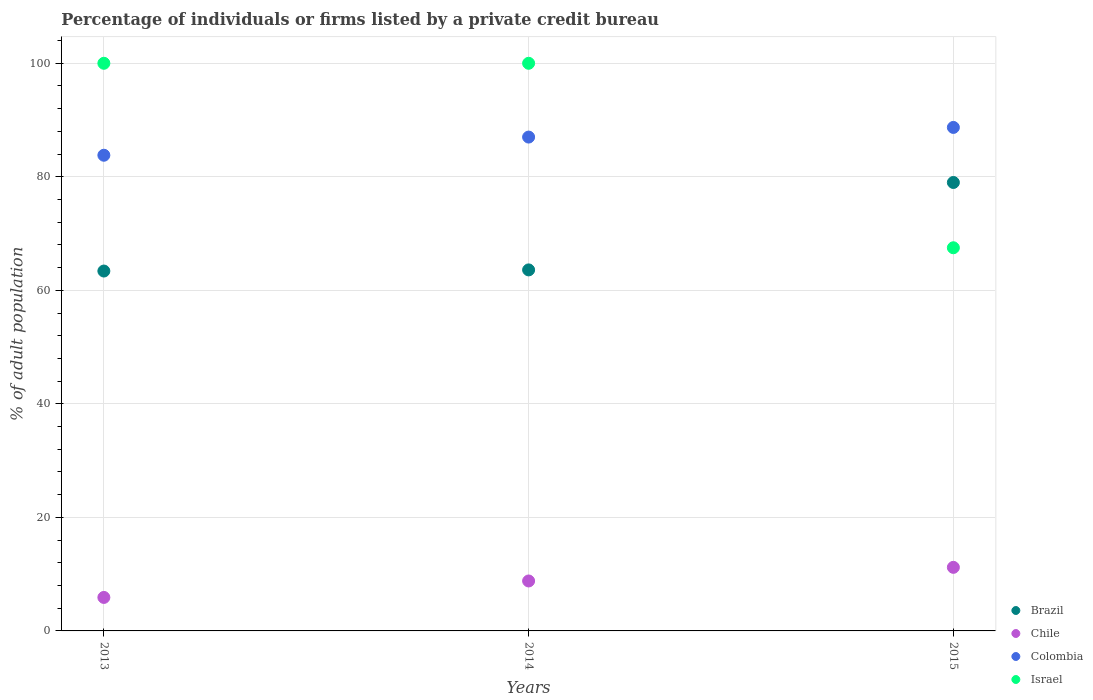What is the percentage of population listed by a private credit bureau in Israel in 2014?
Keep it short and to the point. 100. Across all years, what is the maximum percentage of population listed by a private credit bureau in Brazil?
Provide a succinct answer. 79. Across all years, what is the minimum percentage of population listed by a private credit bureau in Brazil?
Provide a succinct answer. 63.4. In which year was the percentage of population listed by a private credit bureau in Chile maximum?
Your response must be concise. 2015. What is the total percentage of population listed by a private credit bureau in Chile in the graph?
Your answer should be compact. 25.9. What is the difference between the percentage of population listed by a private credit bureau in Israel in 2013 and that in 2014?
Ensure brevity in your answer.  0. What is the difference between the percentage of population listed by a private credit bureau in Israel in 2013 and the percentage of population listed by a private credit bureau in Chile in 2014?
Make the answer very short. 91.2. What is the average percentage of population listed by a private credit bureau in Colombia per year?
Your answer should be compact. 86.5. In the year 2014, what is the difference between the percentage of population listed by a private credit bureau in Colombia and percentage of population listed by a private credit bureau in Brazil?
Keep it short and to the point. 23.4. In how many years, is the percentage of population listed by a private credit bureau in Colombia greater than 56 %?
Provide a succinct answer. 3. What is the ratio of the percentage of population listed by a private credit bureau in Colombia in 2014 to that in 2015?
Offer a terse response. 0.98. What is the difference between the highest and the lowest percentage of population listed by a private credit bureau in Brazil?
Offer a very short reply. 15.6. Is the sum of the percentage of population listed by a private credit bureau in Brazil in 2014 and 2015 greater than the maximum percentage of population listed by a private credit bureau in Israel across all years?
Your answer should be very brief. Yes. Is it the case that in every year, the sum of the percentage of population listed by a private credit bureau in Chile and percentage of population listed by a private credit bureau in Israel  is greater than the sum of percentage of population listed by a private credit bureau in Colombia and percentage of population listed by a private credit bureau in Brazil?
Provide a succinct answer. No. How many years are there in the graph?
Offer a very short reply. 3. What is the difference between two consecutive major ticks on the Y-axis?
Give a very brief answer. 20. Are the values on the major ticks of Y-axis written in scientific E-notation?
Make the answer very short. No. Does the graph contain grids?
Offer a terse response. Yes. How are the legend labels stacked?
Your answer should be very brief. Vertical. What is the title of the graph?
Offer a very short reply. Percentage of individuals or firms listed by a private credit bureau. Does "Luxembourg" appear as one of the legend labels in the graph?
Offer a very short reply. No. What is the label or title of the X-axis?
Your answer should be very brief. Years. What is the label or title of the Y-axis?
Offer a terse response. % of adult population. What is the % of adult population in Brazil in 2013?
Give a very brief answer. 63.4. What is the % of adult population of Chile in 2013?
Offer a very short reply. 5.9. What is the % of adult population of Colombia in 2013?
Your answer should be compact. 83.8. What is the % of adult population of Israel in 2013?
Your answer should be compact. 100. What is the % of adult population of Brazil in 2014?
Offer a terse response. 63.6. What is the % of adult population of Chile in 2014?
Your response must be concise. 8.8. What is the % of adult population of Israel in 2014?
Make the answer very short. 100. What is the % of adult population of Brazil in 2015?
Provide a succinct answer. 79. What is the % of adult population in Colombia in 2015?
Your response must be concise. 88.7. What is the % of adult population in Israel in 2015?
Your answer should be very brief. 67.5. Across all years, what is the maximum % of adult population in Brazil?
Provide a succinct answer. 79. Across all years, what is the maximum % of adult population of Colombia?
Give a very brief answer. 88.7. Across all years, what is the maximum % of adult population in Israel?
Your answer should be compact. 100. Across all years, what is the minimum % of adult population in Brazil?
Provide a short and direct response. 63.4. Across all years, what is the minimum % of adult population in Colombia?
Ensure brevity in your answer.  83.8. Across all years, what is the minimum % of adult population in Israel?
Your answer should be compact. 67.5. What is the total % of adult population of Brazil in the graph?
Offer a very short reply. 206. What is the total % of adult population in Chile in the graph?
Keep it short and to the point. 25.9. What is the total % of adult population of Colombia in the graph?
Your answer should be very brief. 259.5. What is the total % of adult population of Israel in the graph?
Keep it short and to the point. 267.5. What is the difference between the % of adult population in Chile in 2013 and that in 2014?
Provide a succinct answer. -2.9. What is the difference between the % of adult population of Colombia in 2013 and that in 2014?
Make the answer very short. -3.2. What is the difference between the % of adult population in Brazil in 2013 and that in 2015?
Ensure brevity in your answer.  -15.6. What is the difference between the % of adult population of Chile in 2013 and that in 2015?
Offer a very short reply. -5.3. What is the difference between the % of adult population in Israel in 2013 and that in 2015?
Make the answer very short. 32.5. What is the difference between the % of adult population of Brazil in 2014 and that in 2015?
Provide a succinct answer. -15.4. What is the difference between the % of adult population of Chile in 2014 and that in 2015?
Offer a very short reply. -2.4. What is the difference between the % of adult population in Israel in 2014 and that in 2015?
Provide a succinct answer. 32.5. What is the difference between the % of adult population in Brazil in 2013 and the % of adult population in Chile in 2014?
Keep it short and to the point. 54.6. What is the difference between the % of adult population of Brazil in 2013 and the % of adult population of Colombia in 2014?
Offer a very short reply. -23.6. What is the difference between the % of adult population in Brazil in 2013 and the % of adult population in Israel in 2014?
Offer a terse response. -36.6. What is the difference between the % of adult population of Chile in 2013 and the % of adult population of Colombia in 2014?
Make the answer very short. -81.1. What is the difference between the % of adult population in Chile in 2013 and the % of adult population in Israel in 2014?
Make the answer very short. -94.1. What is the difference between the % of adult population of Colombia in 2013 and the % of adult population of Israel in 2014?
Ensure brevity in your answer.  -16.2. What is the difference between the % of adult population of Brazil in 2013 and the % of adult population of Chile in 2015?
Give a very brief answer. 52.2. What is the difference between the % of adult population of Brazil in 2013 and the % of adult population of Colombia in 2015?
Your answer should be very brief. -25.3. What is the difference between the % of adult population of Chile in 2013 and the % of adult population of Colombia in 2015?
Provide a short and direct response. -82.8. What is the difference between the % of adult population in Chile in 2013 and the % of adult population in Israel in 2015?
Keep it short and to the point. -61.6. What is the difference between the % of adult population of Brazil in 2014 and the % of adult population of Chile in 2015?
Offer a very short reply. 52.4. What is the difference between the % of adult population in Brazil in 2014 and the % of adult population in Colombia in 2015?
Your answer should be very brief. -25.1. What is the difference between the % of adult population in Brazil in 2014 and the % of adult population in Israel in 2015?
Provide a succinct answer. -3.9. What is the difference between the % of adult population of Chile in 2014 and the % of adult population of Colombia in 2015?
Offer a very short reply. -79.9. What is the difference between the % of adult population of Chile in 2014 and the % of adult population of Israel in 2015?
Keep it short and to the point. -58.7. What is the difference between the % of adult population of Colombia in 2014 and the % of adult population of Israel in 2015?
Your answer should be very brief. 19.5. What is the average % of adult population in Brazil per year?
Offer a very short reply. 68.67. What is the average % of adult population of Chile per year?
Give a very brief answer. 8.63. What is the average % of adult population in Colombia per year?
Give a very brief answer. 86.5. What is the average % of adult population of Israel per year?
Your response must be concise. 89.17. In the year 2013, what is the difference between the % of adult population in Brazil and % of adult population in Chile?
Keep it short and to the point. 57.5. In the year 2013, what is the difference between the % of adult population in Brazil and % of adult population in Colombia?
Keep it short and to the point. -20.4. In the year 2013, what is the difference between the % of adult population in Brazil and % of adult population in Israel?
Offer a very short reply. -36.6. In the year 2013, what is the difference between the % of adult population of Chile and % of adult population of Colombia?
Your response must be concise. -77.9. In the year 2013, what is the difference between the % of adult population in Chile and % of adult population in Israel?
Make the answer very short. -94.1. In the year 2013, what is the difference between the % of adult population in Colombia and % of adult population in Israel?
Provide a short and direct response. -16.2. In the year 2014, what is the difference between the % of adult population of Brazil and % of adult population of Chile?
Provide a succinct answer. 54.8. In the year 2014, what is the difference between the % of adult population of Brazil and % of adult population of Colombia?
Provide a succinct answer. -23.4. In the year 2014, what is the difference between the % of adult population in Brazil and % of adult population in Israel?
Ensure brevity in your answer.  -36.4. In the year 2014, what is the difference between the % of adult population of Chile and % of adult population of Colombia?
Offer a very short reply. -78.2. In the year 2014, what is the difference between the % of adult population in Chile and % of adult population in Israel?
Offer a very short reply. -91.2. In the year 2014, what is the difference between the % of adult population in Colombia and % of adult population in Israel?
Provide a succinct answer. -13. In the year 2015, what is the difference between the % of adult population in Brazil and % of adult population in Chile?
Give a very brief answer. 67.8. In the year 2015, what is the difference between the % of adult population of Brazil and % of adult population of Israel?
Keep it short and to the point. 11.5. In the year 2015, what is the difference between the % of adult population of Chile and % of adult population of Colombia?
Your answer should be very brief. -77.5. In the year 2015, what is the difference between the % of adult population of Chile and % of adult population of Israel?
Ensure brevity in your answer.  -56.3. In the year 2015, what is the difference between the % of adult population of Colombia and % of adult population of Israel?
Your answer should be compact. 21.2. What is the ratio of the % of adult population of Chile in 2013 to that in 2014?
Keep it short and to the point. 0.67. What is the ratio of the % of adult population of Colombia in 2013 to that in 2014?
Your response must be concise. 0.96. What is the ratio of the % of adult population of Brazil in 2013 to that in 2015?
Ensure brevity in your answer.  0.8. What is the ratio of the % of adult population of Chile in 2013 to that in 2015?
Keep it short and to the point. 0.53. What is the ratio of the % of adult population of Colombia in 2013 to that in 2015?
Your response must be concise. 0.94. What is the ratio of the % of adult population in Israel in 2013 to that in 2015?
Give a very brief answer. 1.48. What is the ratio of the % of adult population in Brazil in 2014 to that in 2015?
Offer a terse response. 0.81. What is the ratio of the % of adult population of Chile in 2014 to that in 2015?
Provide a succinct answer. 0.79. What is the ratio of the % of adult population in Colombia in 2014 to that in 2015?
Ensure brevity in your answer.  0.98. What is the ratio of the % of adult population in Israel in 2014 to that in 2015?
Offer a terse response. 1.48. What is the difference between the highest and the second highest % of adult population of Brazil?
Your answer should be compact. 15.4. What is the difference between the highest and the second highest % of adult population in Colombia?
Offer a terse response. 1.7. What is the difference between the highest and the second highest % of adult population of Israel?
Provide a short and direct response. 0. What is the difference between the highest and the lowest % of adult population in Chile?
Your response must be concise. 5.3. What is the difference between the highest and the lowest % of adult population in Colombia?
Make the answer very short. 4.9. What is the difference between the highest and the lowest % of adult population in Israel?
Provide a succinct answer. 32.5. 